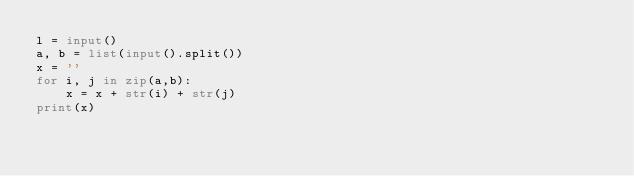<code> <loc_0><loc_0><loc_500><loc_500><_Python_>l = input()
a, b = list(input().split())
x = ''
for i, j in zip(a,b):
    x = x + str(i) + str(j)
print(x)</code> 